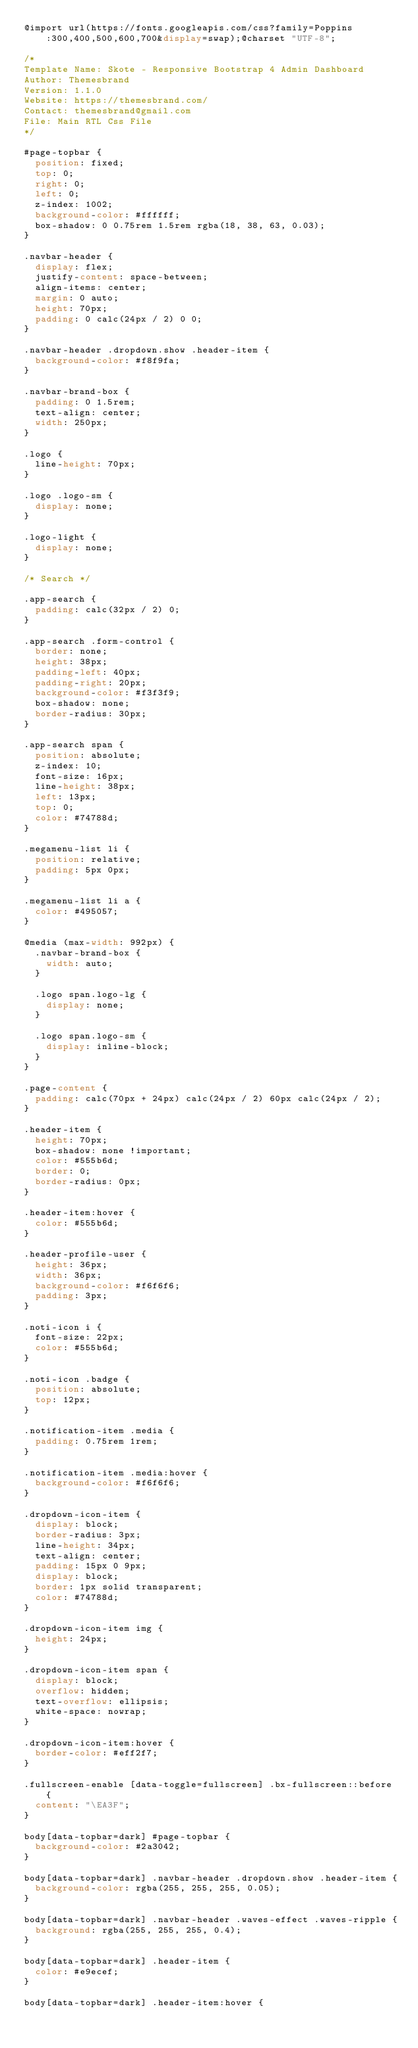Convert code to text. <code><loc_0><loc_0><loc_500><loc_500><_CSS_>@import url(https://fonts.googleapis.com/css?family=Poppins:300,400,500,600,700&display=swap);@charset "UTF-8";

/*
Template Name: Skote - Responsive Bootstrap 4 Admin Dashboard
Author: Themesbrand
Version: 1.1.0
Website: https://themesbrand.com/
Contact: themesbrand@gmail.com
File: Main RTL Css File
*/

#page-topbar {
  position: fixed;
  top: 0;
  right: 0;
  left: 0;
  z-index: 1002;
  background-color: #ffffff;
  box-shadow: 0 0.75rem 1.5rem rgba(18, 38, 63, 0.03);
}

.navbar-header {
  display: flex;
  justify-content: space-between;
  align-items: center;
  margin: 0 auto;
  height: 70px;
  padding: 0 calc(24px / 2) 0 0;
}

.navbar-header .dropdown.show .header-item {
  background-color: #f8f9fa;
}

.navbar-brand-box {
  padding: 0 1.5rem;
  text-align: center;
  width: 250px;
}

.logo {
  line-height: 70px;
}

.logo .logo-sm {
  display: none;
}

.logo-light {
  display: none;
}

/* Search */

.app-search {
  padding: calc(32px / 2) 0;
}

.app-search .form-control {
  border: none;
  height: 38px;
  padding-left: 40px;
  padding-right: 20px;
  background-color: #f3f3f9;
  box-shadow: none;
  border-radius: 30px;
}

.app-search span {
  position: absolute;
  z-index: 10;
  font-size: 16px;
  line-height: 38px;
  left: 13px;
  top: 0;
  color: #74788d;
}

.megamenu-list li {
  position: relative;
  padding: 5px 0px;
}

.megamenu-list li a {
  color: #495057;
}

@media (max-width: 992px) {
  .navbar-brand-box {
    width: auto;
  }

  .logo span.logo-lg {
    display: none;
  }

  .logo span.logo-sm {
    display: inline-block;
  }
}

.page-content {
  padding: calc(70px + 24px) calc(24px / 2) 60px calc(24px / 2);
}

.header-item {
  height: 70px;
  box-shadow: none !important;
  color: #555b6d;
  border: 0;
  border-radius: 0px;
}

.header-item:hover {
  color: #555b6d;
}

.header-profile-user {
  height: 36px;
  width: 36px;
  background-color: #f6f6f6;
  padding: 3px;
}

.noti-icon i {
  font-size: 22px;
  color: #555b6d;
}

.noti-icon .badge {
  position: absolute;
  top: 12px;
}

.notification-item .media {
  padding: 0.75rem 1rem;
}

.notification-item .media:hover {
  background-color: #f6f6f6;
}

.dropdown-icon-item {
  display: block;
  border-radius: 3px;
  line-height: 34px;
  text-align: center;
  padding: 15px 0 9px;
  display: block;
  border: 1px solid transparent;
  color: #74788d;
}

.dropdown-icon-item img {
  height: 24px;
}

.dropdown-icon-item span {
  display: block;
  overflow: hidden;
  text-overflow: ellipsis;
  white-space: nowrap;
}

.dropdown-icon-item:hover {
  border-color: #eff2f7;
}

.fullscreen-enable [data-toggle=fullscreen] .bx-fullscreen::before {
  content: "\EA3F";
}

body[data-topbar=dark] #page-topbar {
  background-color: #2a3042;
}

body[data-topbar=dark] .navbar-header .dropdown.show .header-item {
  background-color: rgba(255, 255, 255, 0.05);
}

body[data-topbar=dark] .navbar-header .waves-effect .waves-ripple {
  background: rgba(255, 255, 255, 0.4);
}

body[data-topbar=dark] .header-item {
  color: #e9ecef;
}

body[data-topbar=dark] .header-item:hover {</code> 